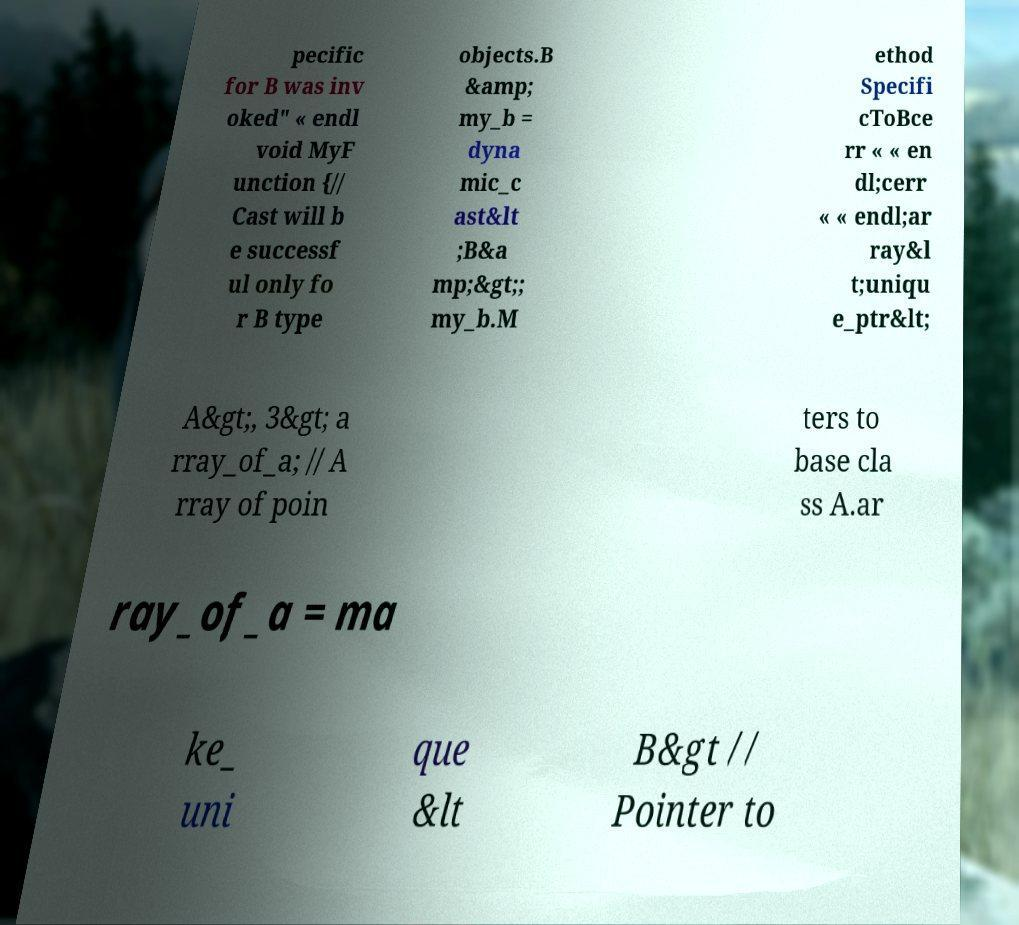For documentation purposes, I need the text within this image transcribed. Could you provide that? pecific for B was inv oked" « endl void MyF unction {// Cast will b e successf ul only fo r B type objects.B &amp; my_b = dyna mic_c ast&lt ;B&a mp;&gt;; my_b.M ethod Specifi cToBce rr « « en dl;cerr « « endl;ar ray&l t;uniqu e_ptr&lt; A&gt;, 3&gt; a rray_of_a; // A rray of poin ters to base cla ss A.ar ray_of_a = ma ke_ uni que &lt B&gt // Pointer to 